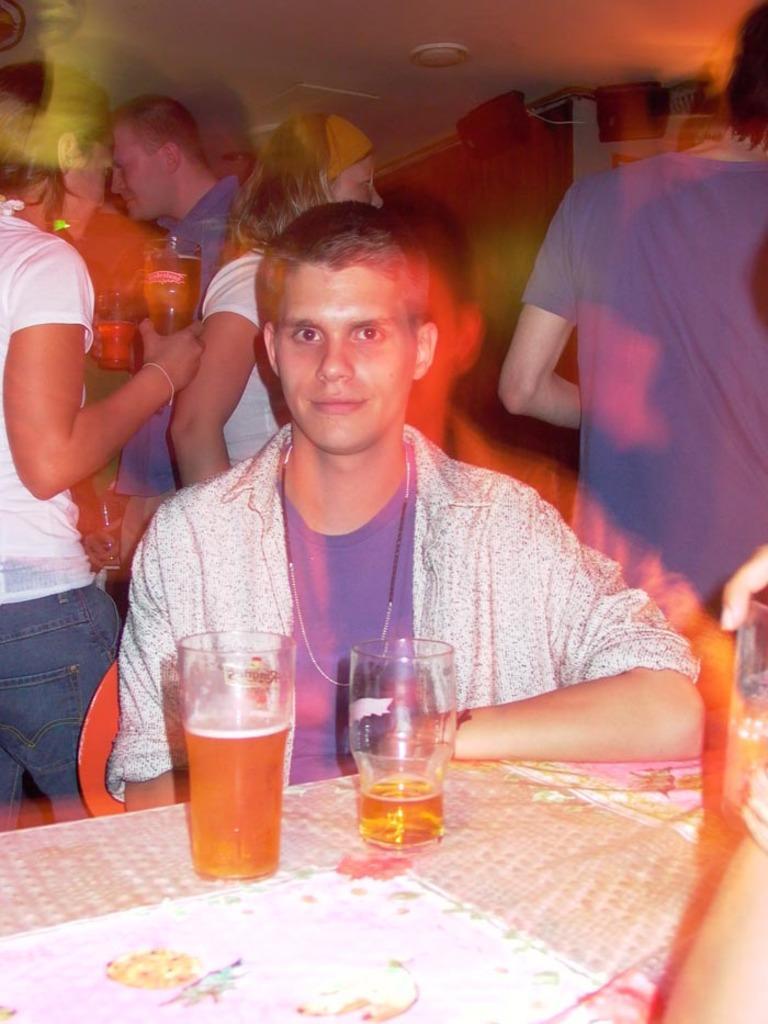Please provide a concise description of this image. In this image a person is sitting on the chair. Before him there is a table having two glasses. Glasses are filled with drinks. Left side there is a person wearing white shirt is holding a glass in his hand. A person wearing blue shirt is holding glass which is filled with drink. There are few persons standing. Behind them there is wall. 